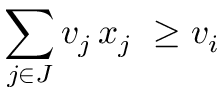<formula> <loc_0><loc_0><loc_500><loc_500>\sum _ { j \in J } v _ { j } \, x _ { j } \ \geq v _ { i }</formula> 